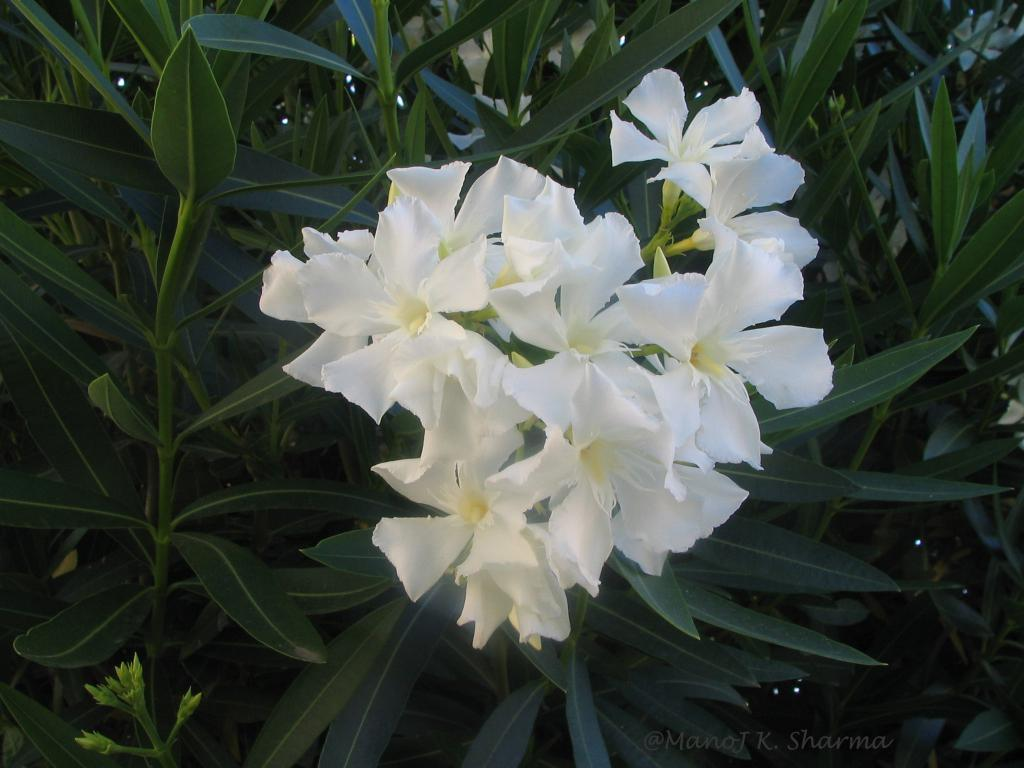What type of flora is present in the image? There are flowers in the image. What color are the flowers? The flowers are white in color. What can be seen in the background of the image? There are green leaves in the background of the image. How many pies are stacked on top of each other in the image? There are no pies present in the image; it features flowers and green leaves. What type of twist can be seen in the image? There is no twist present in the image; it features flowers and green leaves. 